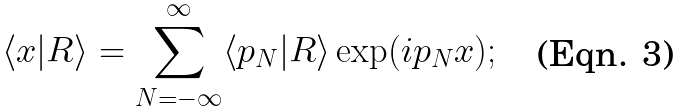<formula> <loc_0><loc_0><loc_500><loc_500>\langle x | R \rangle = \sum _ { N = - \infty } ^ { \infty } \langle p _ { N } | R \rangle \exp ( i p _ { N } x ) ;</formula> 